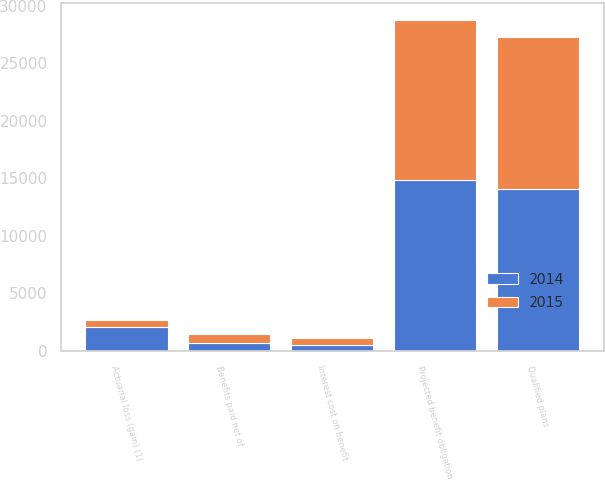Convert chart. <chart><loc_0><loc_0><loc_500><loc_500><stacked_bar_chart><ecel><fcel>Projected benefit obligation<fcel>Interest cost on benefit<fcel>Actuarial loss (gain) (1)<fcel>Benefits paid net of<fcel>Qualified plans<nl><fcel>2015<fcel>13943<fcel>553<fcel>649<fcel>751<fcel>13231<nl><fcel>2014<fcel>14839<fcel>541<fcel>2077<fcel>701<fcel>14060<nl></chart> 